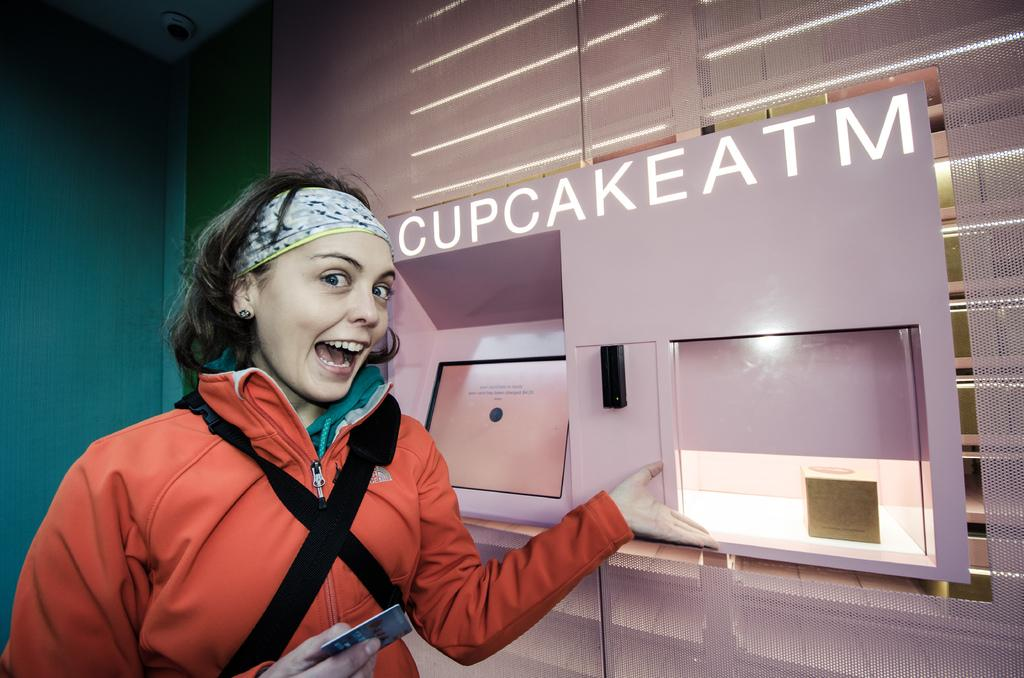<image>
Create a compact narrative representing the image presented. A smiling woman in a red jacket in front of a Cupcake ATM. 